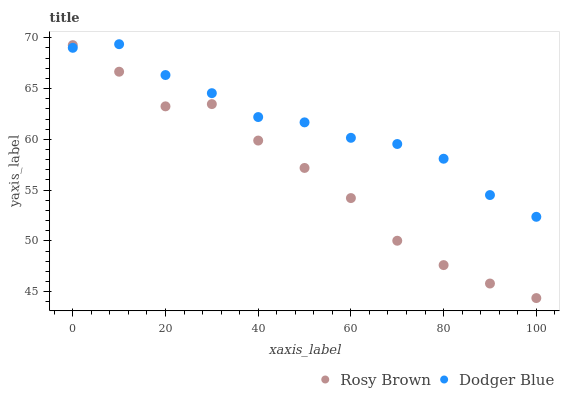Does Rosy Brown have the minimum area under the curve?
Answer yes or no. Yes. Does Dodger Blue have the maximum area under the curve?
Answer yes or no. Yes. Does Dodger Blue have the minimum area under the curve?
Answer yes or no. No. Is Dodger Blue the smoothest?
Answer yes or no. Yes. Is Rosy Brown the roughest?
Answer yes or no. Yes. Is Dodger Blue the roughest?
Answer yes or no. No. Does Rosy Brown have the lowest value?
Answer yes or no. Yes. Does Dodger Blue have the lowest value?
Answer yes or no. No. Does Dodger Blue have the highest value?
Answer yes or no. Yes. Does Rosy Brown intersect Dodger Blue?
Answer yes or no. Yes. Is Rosy Brown less than Dodger Blue?
Answer yes or no. No. Is Rosy Brown greater than Dodger Blue?
Answer yes or no. No. 